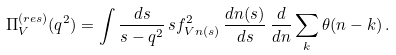<formula> <loc_0><loc_0><loc_500><loc_500>\Pi _ { V } ^ { ( r e s ) } ( q ^ { 2 } ) = \int \frac { d s } { s - q ^ { 2 } } \, s f _ { V n ( s ) } ^ { 2 } \, \frac { d n ( s ) } { d s } \, \frac { d } { d n } \sum _ { k } \theta ( n - k ) \, .</formula> 